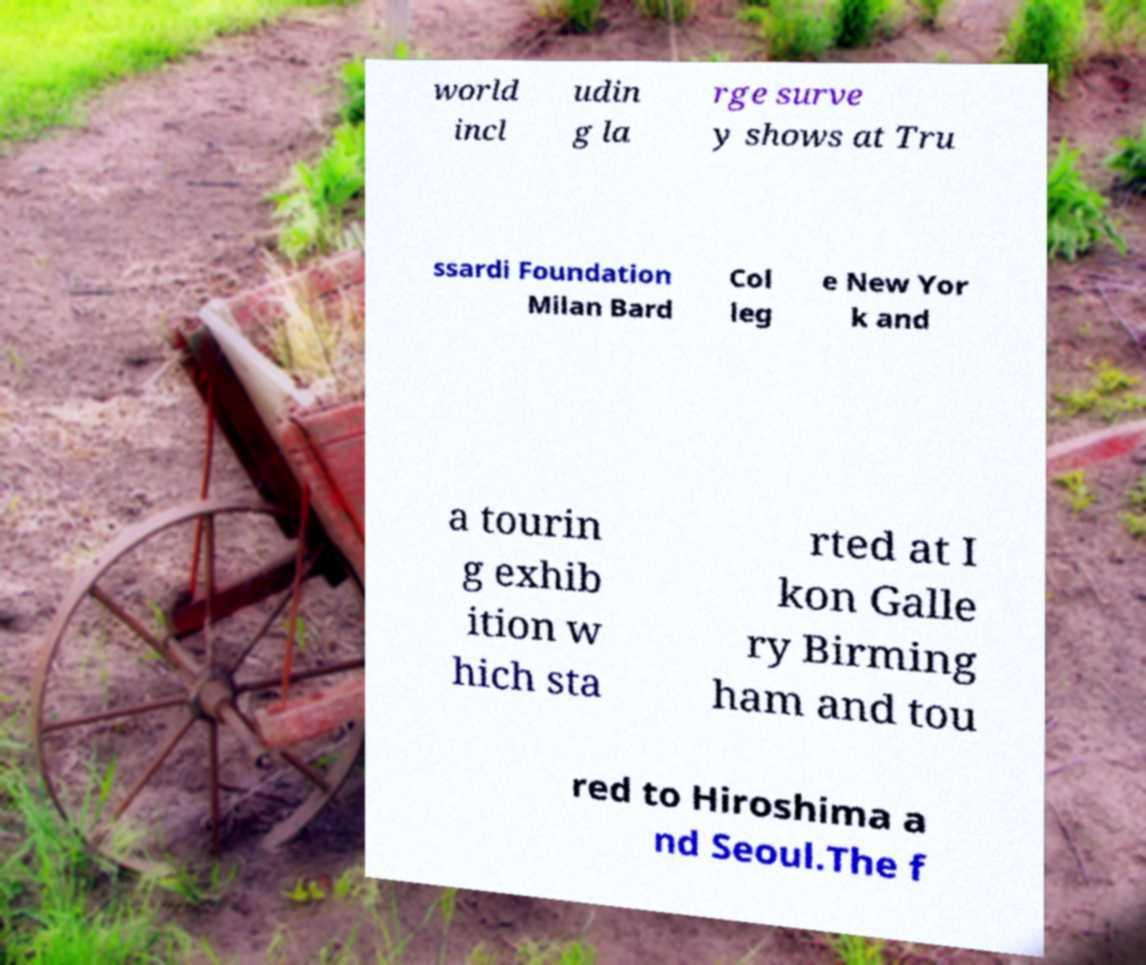Please read and relay the text visible in this image. What does it say? world incl udin g la rge surve y shows at Tru ssardi Foundation Milan Bard Col leg e New Yor k and a tourin g exhib ition w hich sta rted at I kon Galle ry Birming ham and tou red to Hiroshima a nd Seoul.The f 